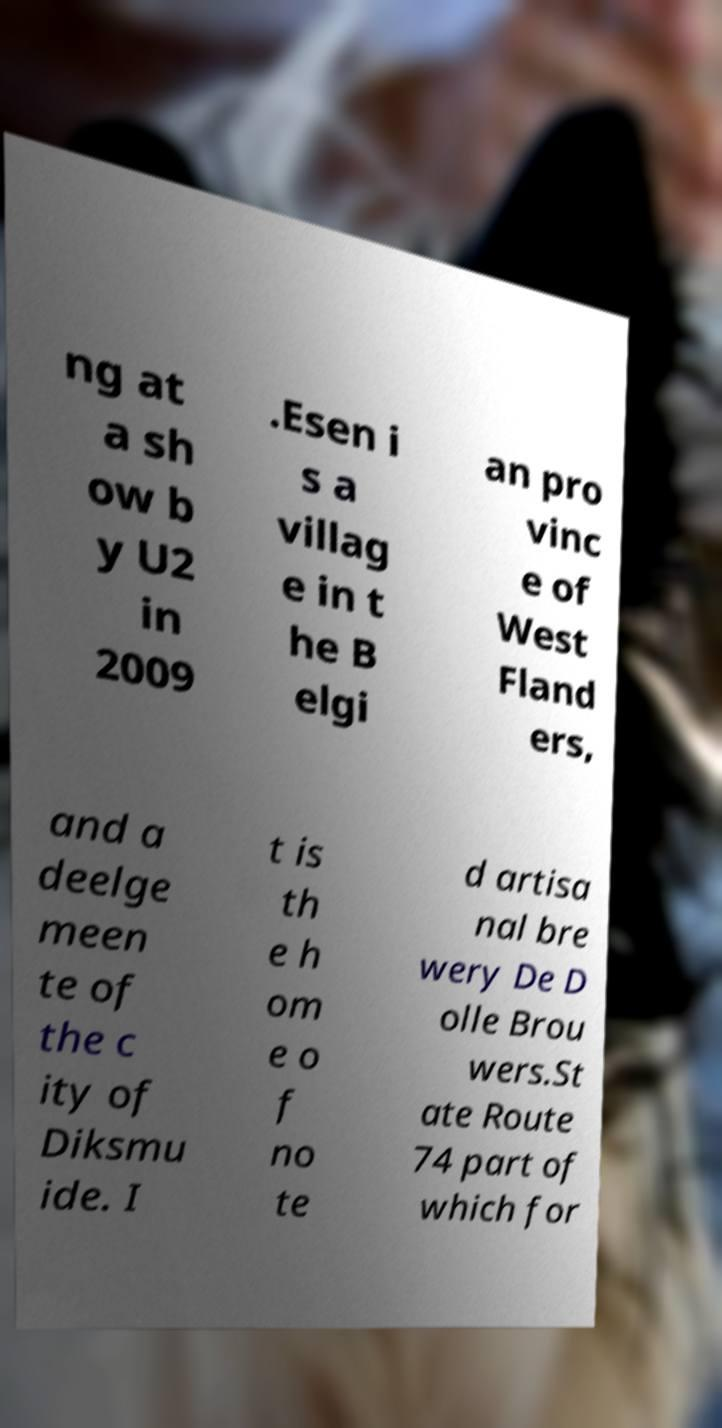Could you assist in decoding the text presented in this image and type it out clearly? ng at a sh ow b y U2 in 2009 .Esen i s a villag e in t he B elgi an pro vinc e of West Fland ers, and a deelge meen te of the c ity of Diksmu ide. I t is th e h om e o f no te d artisa nal bre wery De D olle Brou wers.St ate Route 74 part of which for 